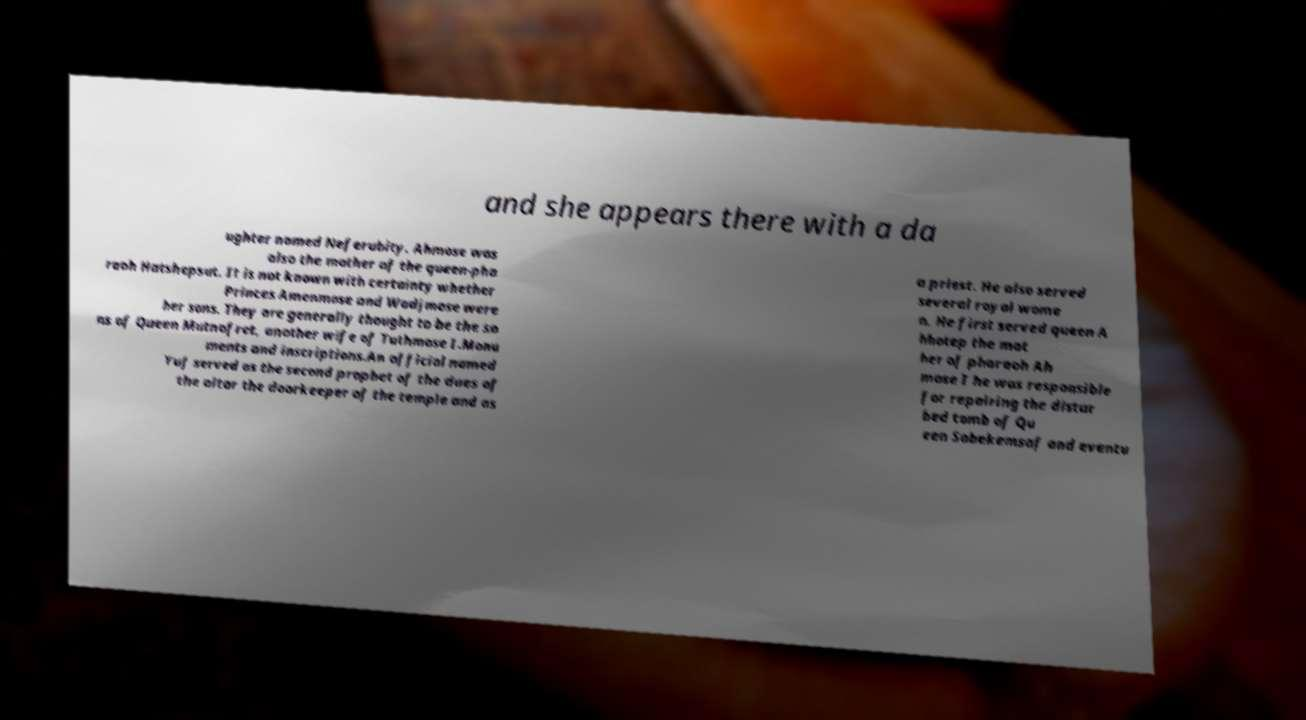There's text embedded in this image that I need extracted. Can you transcribe it verbatim? and she appears there with a da ughter named Neferubity. Ahmose was also the mother of the queen-pha raoh Hatshepsut. It is not known with certainty whether Princes Amenmose and Wadjmose were her sons. They are generally thought to be the so ns of Queen Mutnofret, another wife of Tuthmose I.Monu ments and inscriptions.An official named Yuf served as the second prophet of the dues of the altar the doorkeeper of the temple and as a priest. He also served several royal wome n. He first served queen A hhotep the mot her of pharaoh Ah mose I he was responsible for repairing the distur bed tomb of Qu een Sobekemsaf and eventu 